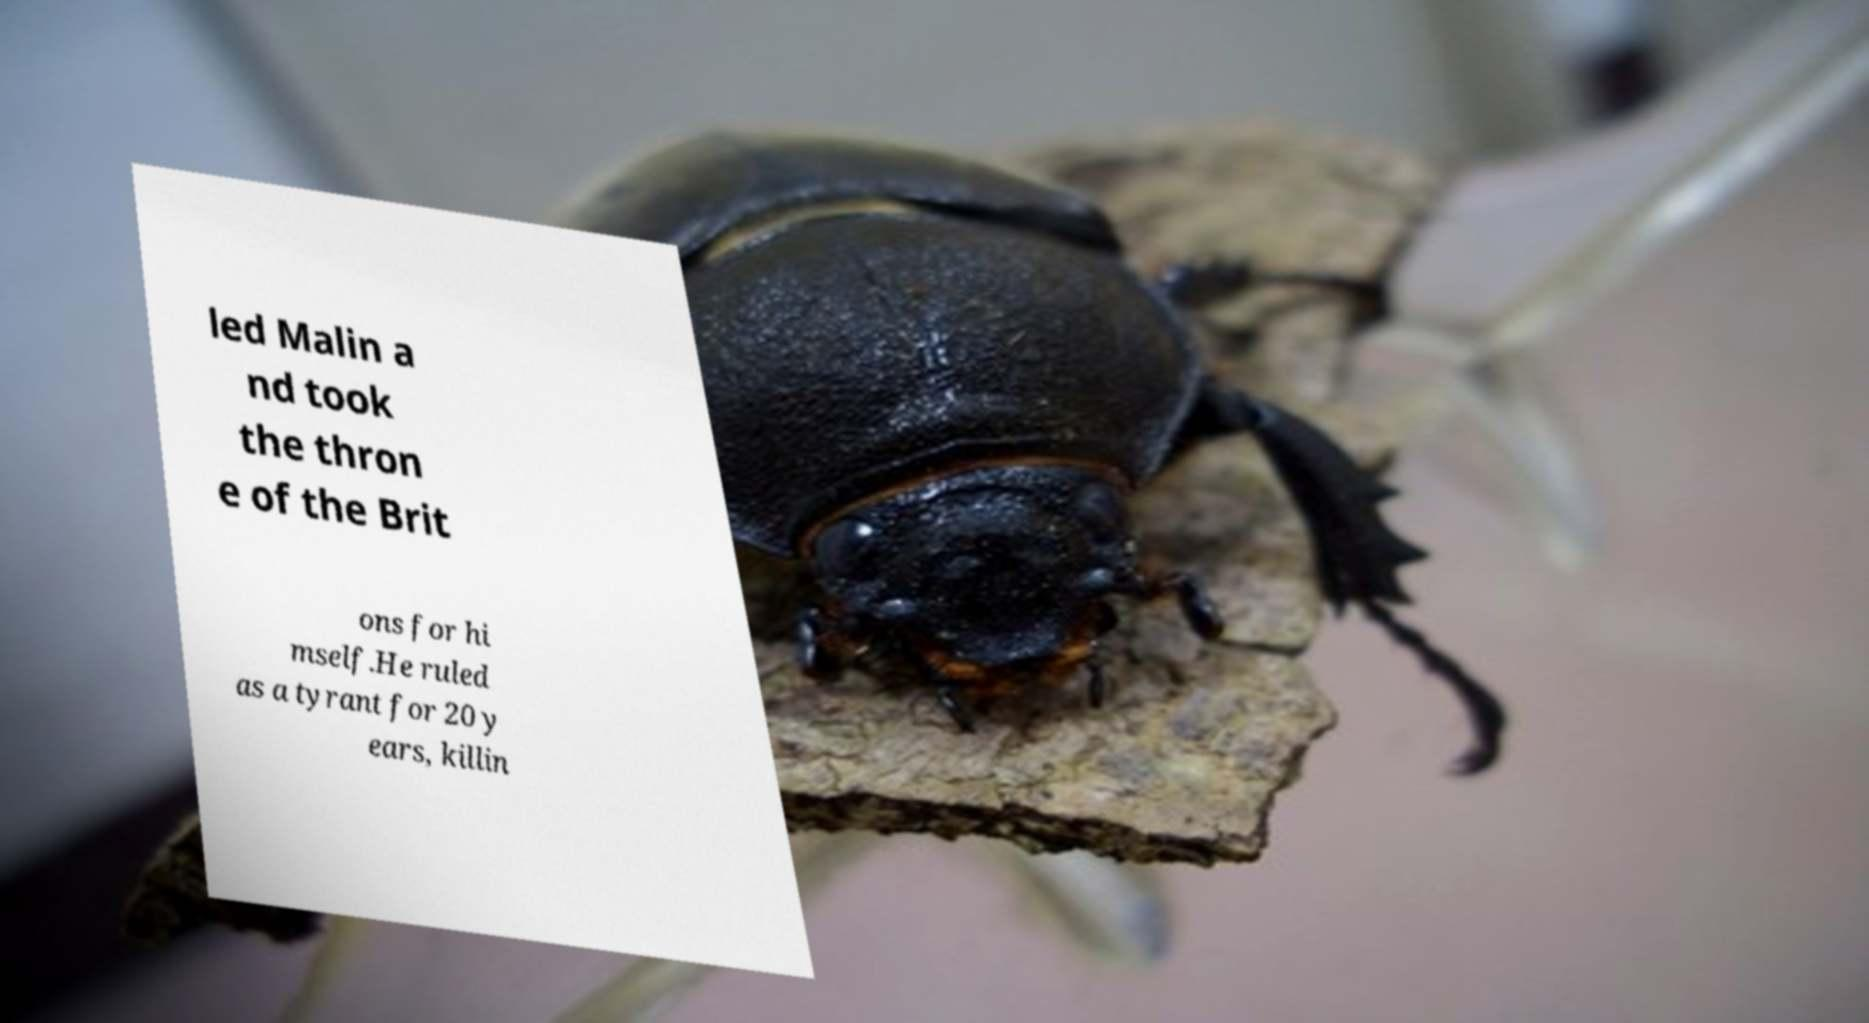Could you assist in decoding the text presented in this image and type it out clearly? led Malin a nd took the thron e of the Brit ons for hi mself.He ruled as a tyrant for 20 y ears, killin 